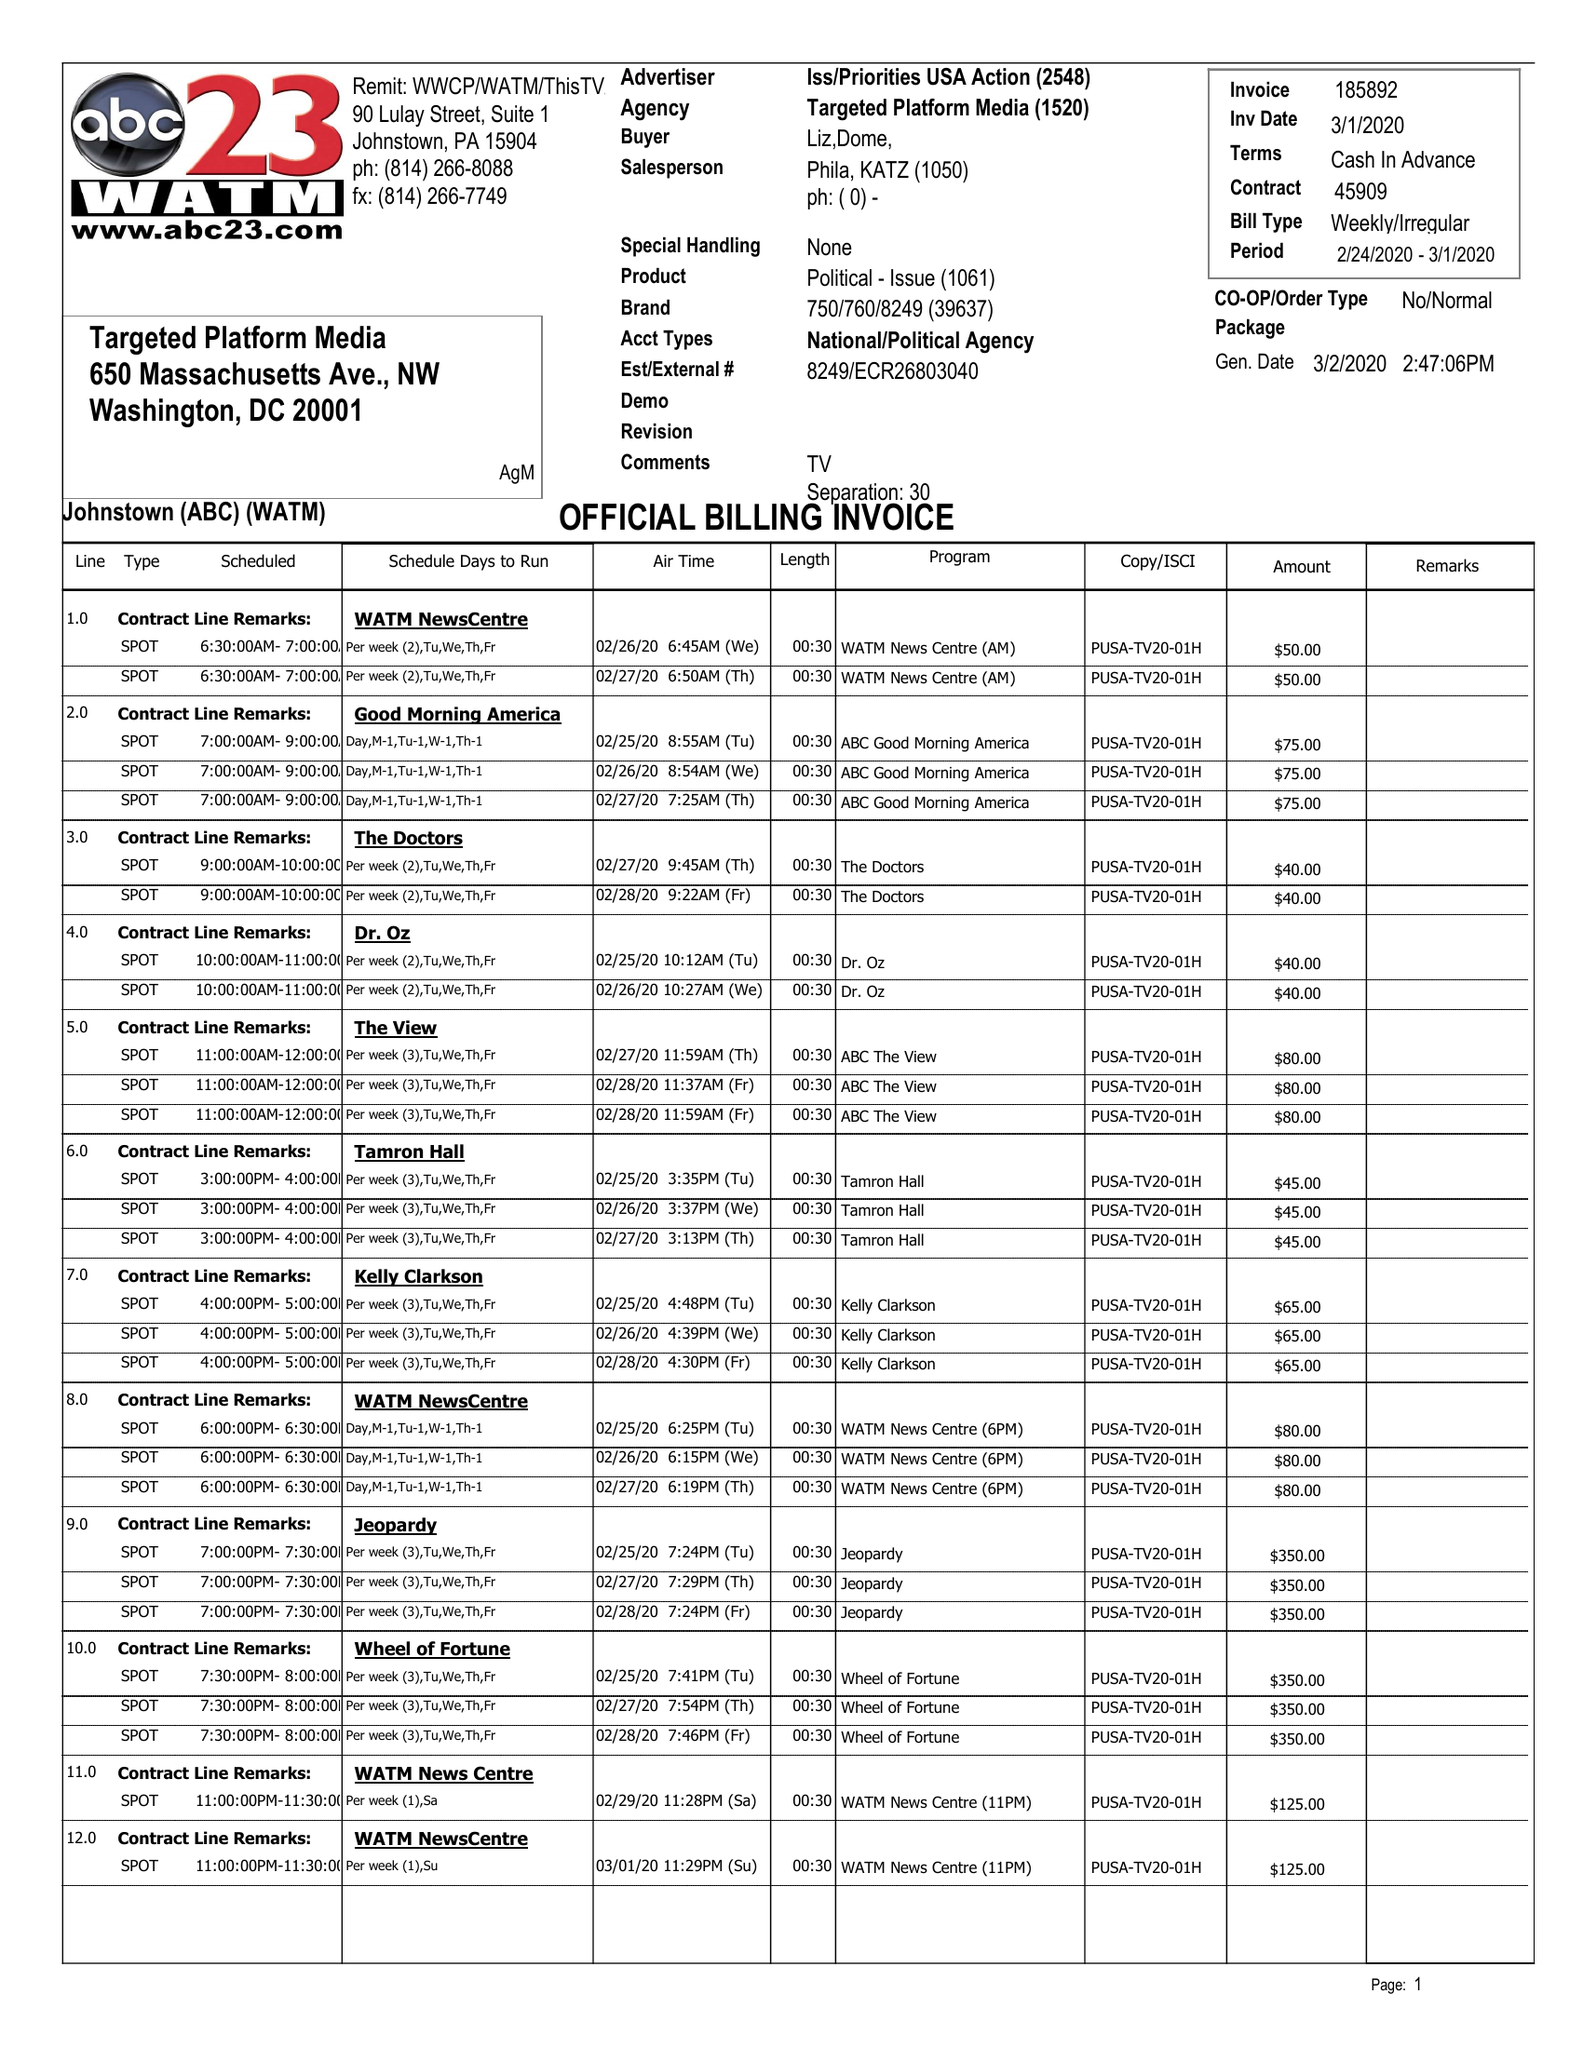What is the value for the flight_to?
Answer the question using a single word or phrase. 03/01/20 